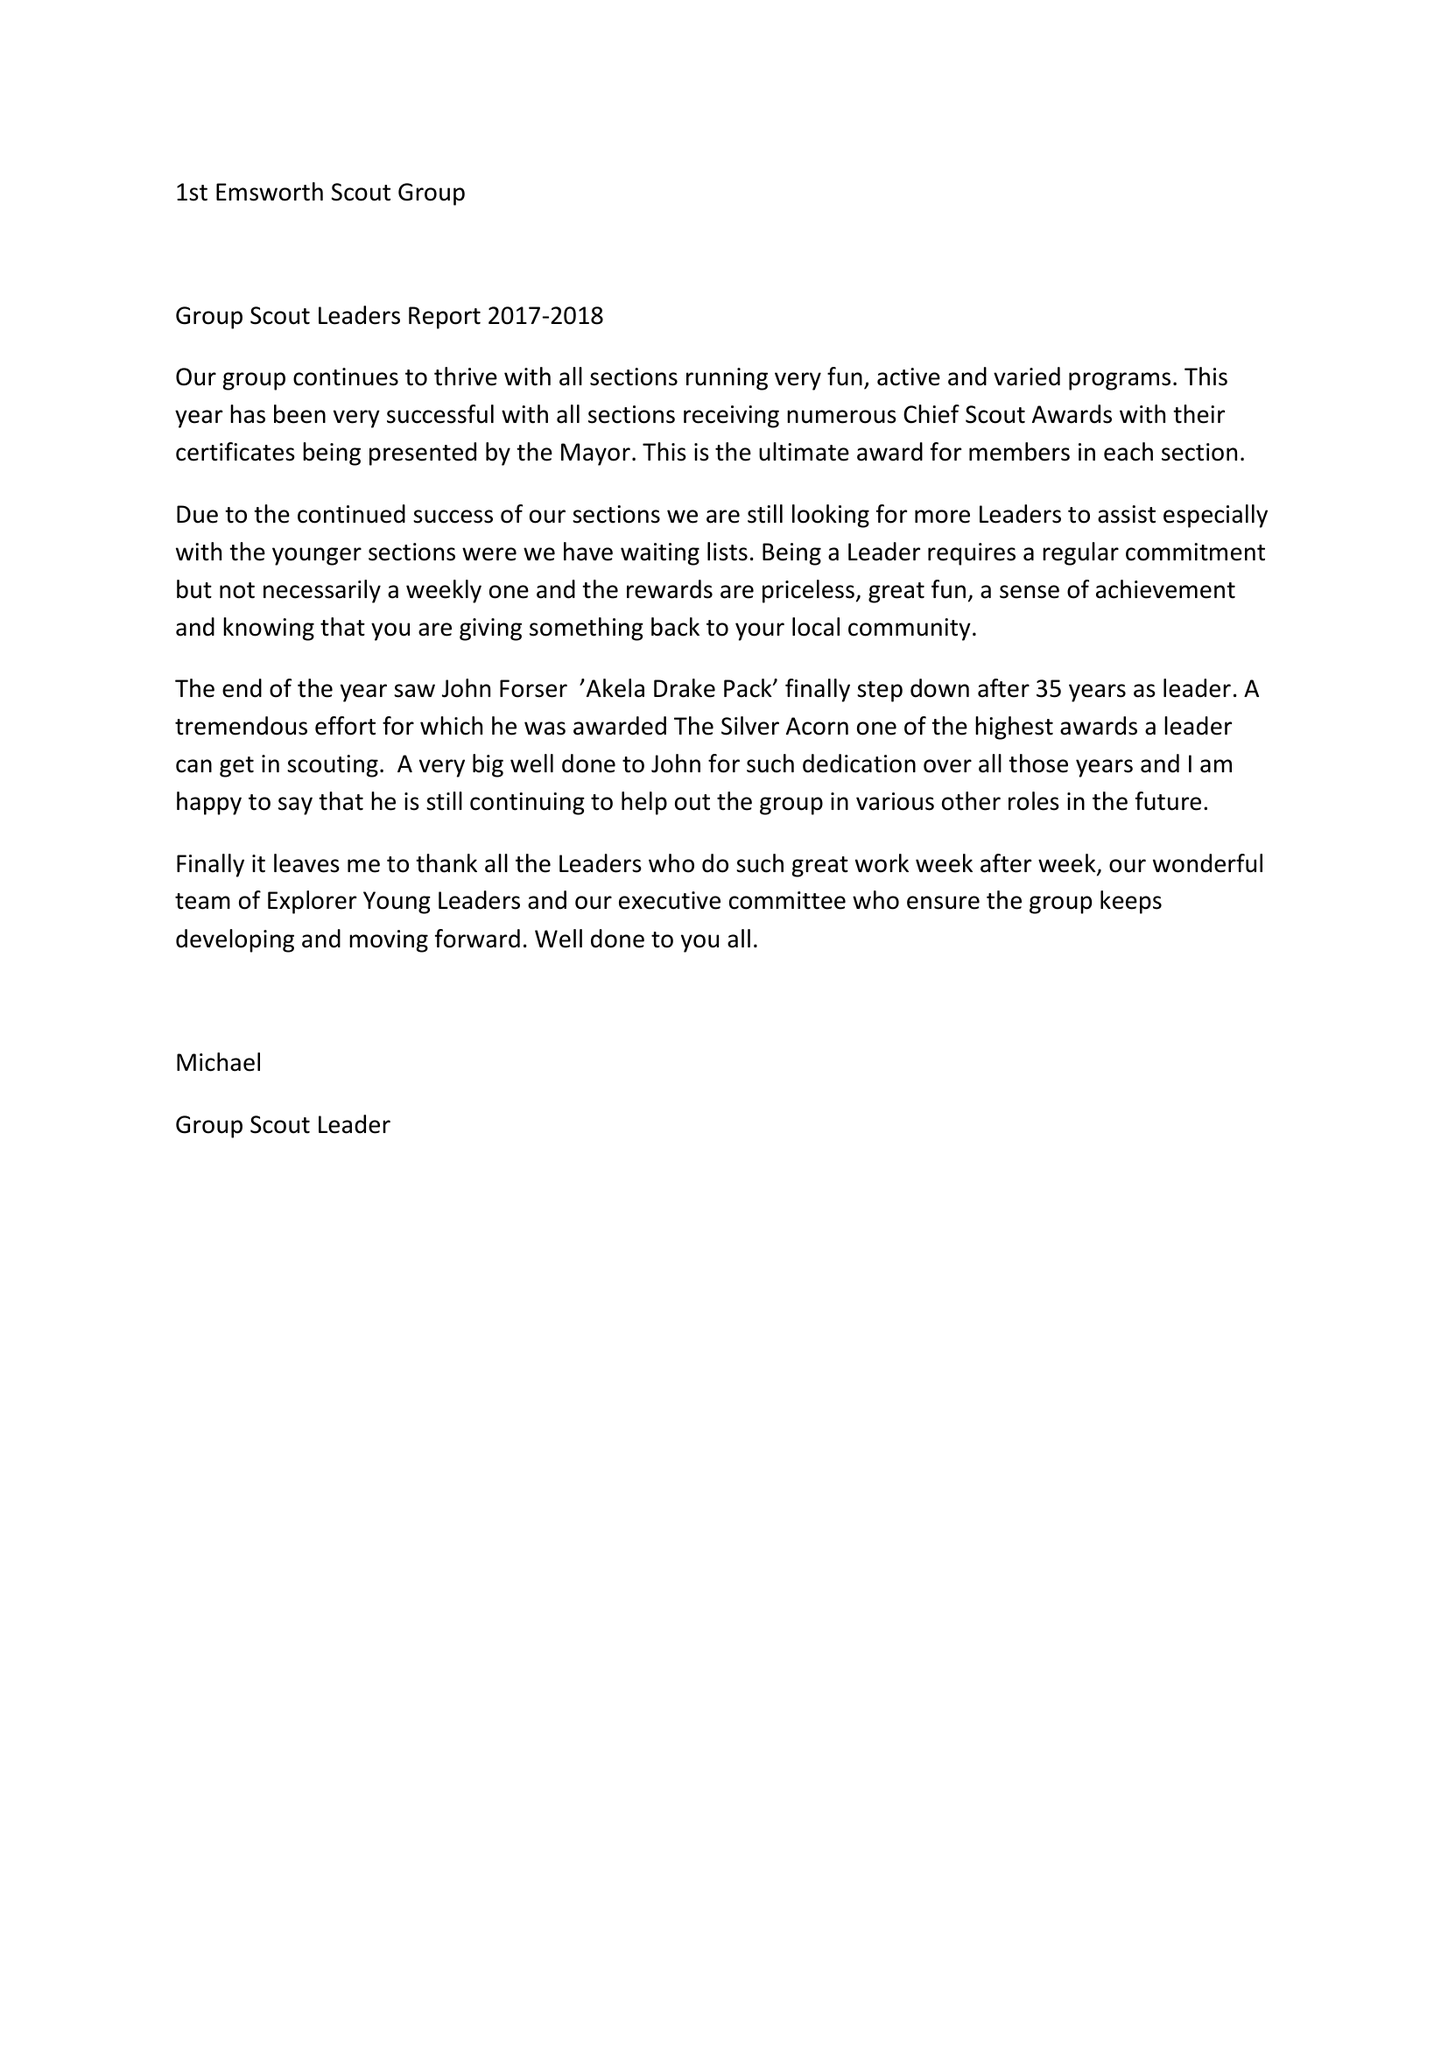What is the value for the report_date?
Answer the question using a single word or phrase. 2018-03-31 